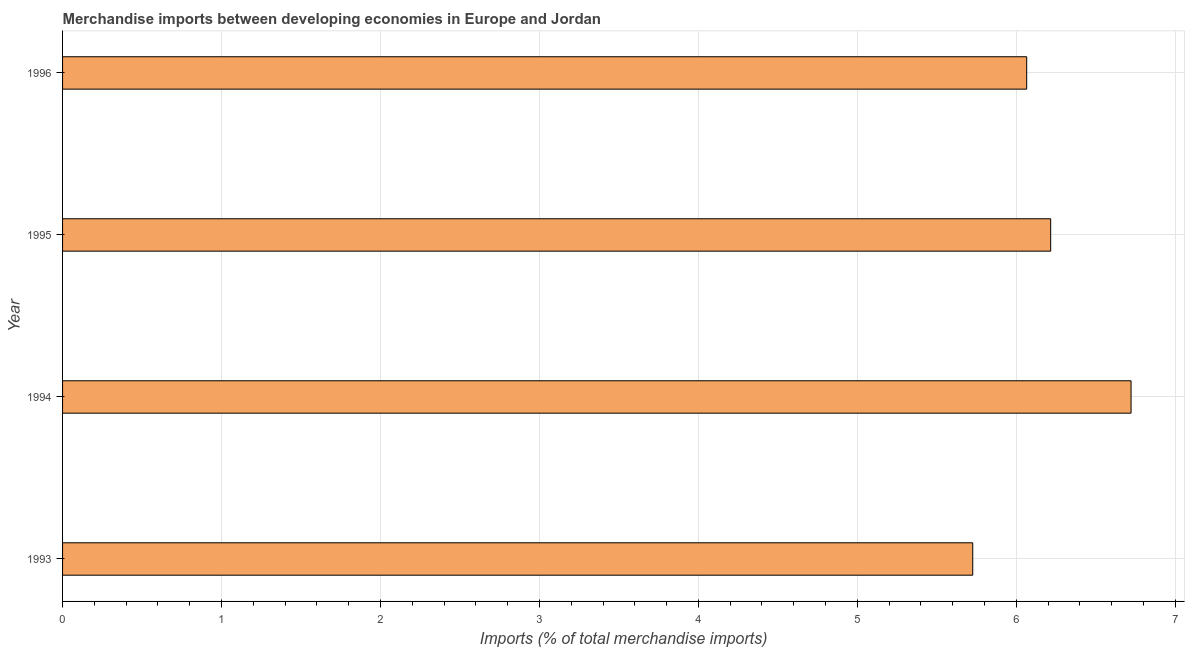Does the graph contain any zero values?
Make the answer very short. No. Does the graph contain grids?
Provide a short and direct response. Yes. What is the title of the graph?
Your answer should be compact. Merchandise imports between developing economies in Europe and Jordan. What is the label or title of the X-axis?
Provide a short and direct response. Imports (% of total merchandise imports). What is the label or title of the Y-axis?
Offer a very short reply. Year. What is the merchandise imports in 1994?
Provide a succinct answer. 6.72. Across all years, what is the maximum merchandise imports?
Provide a short and direct response. 6.72. Across all years, what is the minimum merchandise imports?
Your response must be concise. 5.73. In which year was the merchandise imports minimum?
Give a very brief answer. 1993. What is the sum of the merchandise imports?
Your answer should be very brief. 24.73. What is the difference between the merchandise imports in 1994 and 1996?
Ensure brevity in your answer.  0.66. What is the average merchandise imports per year?
Provide a short and direct response. 6.18. What is the median merchandise imports?
Ensure brevity in your answer.  6.14. In how many years, is the merchandise imports greater than 4 %?
Offer a terse response. 4. Do a majority of the years between 1995 and 1994 (inclusive) have merchandise imports greater than 1 %?
Offer a terse response. No. What is the ratio of the merchandise imports in 1993 to that in 1995?
Provide a short and direct response. 0.92. Is the difference between the merchandise imports in 1993 and 1996 greater than the difference between any two years?
Provide a succinct answer. No. What is the difference between the highest and the second highest merchandise imports?
Your answer should be compact. 0.51. Is the sum of the merchandise imports in 1994 and 1996 greater than the maximum merchandise imports across all years?
Give a very brief answer. Yes. What is the difference between the highest and the lowest merchandise imports?
Your answer should be compact. 1. What is the difference between two consecutive major ticks on the X-axis?
Your answer should be compact. 1. What is the Imports (% of total merchandise imports) in 1993?
Keep it short and to the point. 5.73. What is the Imports (% of total merchandise imports) in 1994?
Give a very brief answer. 6.72. What is the Imports (% of total merchandise imports) of 1995?
Offer a very short reply. 6.22. What is the Imports (% of total merchandise imports) in 1996?
Ensure brevity in your answer.  6.07. What is the difference between the Imports (% of total merchandise imports) in 1993 and 1994?
Offer a terse response. -1. What is the difference between the Imports (% of total merchandise imports) in 1993 and 1995?
Provide a succinct answer. -0.49. What is the difference between the Imports (% of total merchandise imports) in 1993 and 1996?
Offer a terse response. -0.34. What is the difference between the Imports (% of total merchandise imports) in 1994 and 1995?
Ensure brevity in your answer.  0.51. What is the difference between the Imports (% of total merchandise imports) in 1994 and 1996?
Your answer should be very brief. 0.66. What is the difference between the Imports (% of total merchandise imports) in 1995 and 1996?
Provide a short and direct response. 0.15. What is the ratio of the Imports (% of total merchandise imports) in 1993 to that in 1994?
Your response must be concise. 0.85. What is the ratio of the Imports (% of total merchandise imports) in 1993 to that in 1995?
Your answer should be compact. 0.92. What is the ratio of the Imports (% of total merchandise imports) in 1993 to that in 1996?
Keep it short and to the point. 0.94. What is the ratio of the Imports (% of total merchandise imports) in 1994 to that in 1995?
Offer a very short reply. 1.08. What is the ratio of the Imports (% of total merchandise imports) in 1994 to that in 1996?
Offer a very short reply. 1.11. What is the ratio of the Imports (% of total merchandise imports) in 1995 to that in 1996?
Your response must be concise. 1.02. 